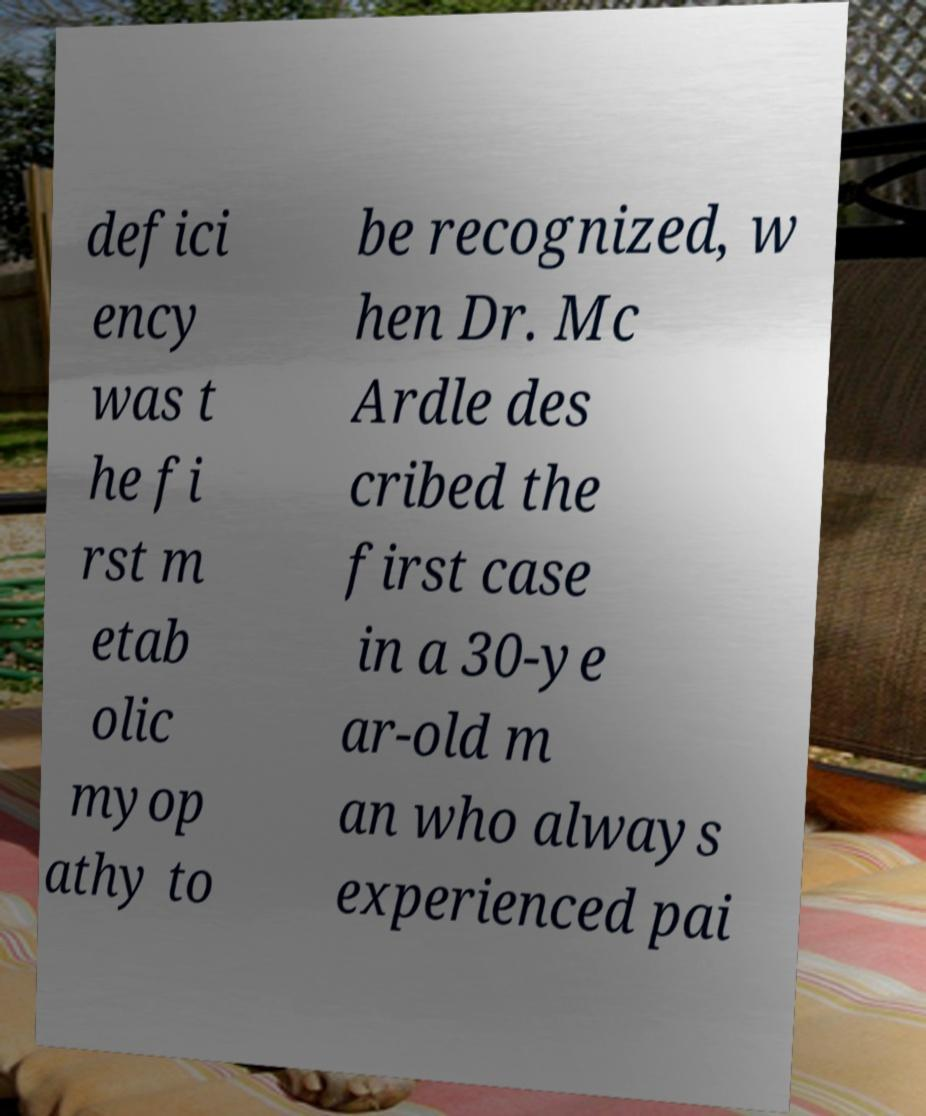For documentation purposes, I need the text within this image transcribed. Could you provide that? defici ency was t he fi rst m etab olic myop athy to be recognized, w hen Dr. Mc Ardle des cribed the first case in a 30-ye ar-old m an who always experienced pai 